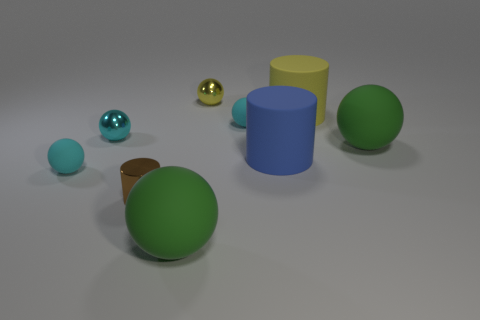How many large matte objects are both on the right side of the yellow ball and in front of the small brown object?
Offer a very short reply. 0. Do the brown cylinder and the yellow ball have the same material?
Provide a short and direct response. Yes. The small shiny thing on the right side of the large green matte sphere that is on the left side of the big blue thing that is to the right of the small yellow ball is what shape?
Offer a terse response. Sphere. Are there fewer tiny yellow objects in front of the big blue object than blue matte cylinders on the right side of the yellow rubber object?
Make the answer very short. No. What shape is the big green object right of the green ball left of the small yellow thing?
Provide a short and direct response. Sphere. Is there anything else that has the same color as the small cylinder?
Your answer should be very brief. No. How many gray things are either big matte balls or tiny cylinders?
Provide a succinct answer. 0. Are there fewer brown shiny cylinders behind the brown object than small rubber balls?
Keep it short and to the point. Yes. What number of small balls are left of the green ball to the left of the yellow cylinder?
Give a very brief answer. 2. How many other things are there of the same size as the yellow shiny sphere?
Keep it short and to the point. 4. 